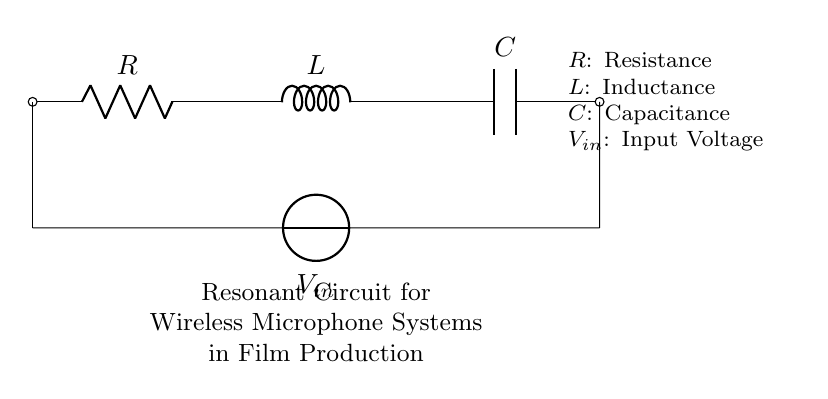What are the components in this circuit? The circuit includes a resistor, an inductor, and a capacitor, which are the basic components of a resonant circuit. Each component is labeled directly in the circuit diagram.
Answer: Resistor, Inductor, Capacitor What is the input voltage labeled as? The input voltage in the circuit is labeled as V_sub_in, which denotes the voltage provided to the circuit. This can be recognized by examining the voltage label directly on the circuit diagram.
Answer: V_sub_in How are the components connected in the circuit? The components are connected in series, starting from the resistor to the inductor, and then to the capacitor. This connection can be deduced by following the lines connecting each component in the circuit diagram.
Answer: In series What is the role of the resonant circuit in wireless microphone systems? The resonant circuit is utilized to filter and amplify the specific frequency signals transmitted by a wireless microphone, ensuring better signal clarity. This role is understood from the context of wireless transmission technologies used in microphone systems.
Answer: Signal filtering and amplification What is the effect of changing the resistance in this circuit? Changing the resistance affects the quality factor of the resonant circuit, which influences bandwidth and sensitivity. By analyzing the relationships among R, L, and C, we understand how resistance alters circuit behavior in resonant circuits.
Answer: Affects quality factor What is the relationship between resistance, inductance, and capacitance in determining resonance? The resonance frequency is determined by the formula f equals one over two pi times the square root of L times C. This shows that both inductance and capacitance are crucial in setting the resonant frequency, while resistance modifies the circuit's behavior at resonance.
Answer: Frequency equation What does the resonant frequency depend on specifically? The resonant frequency depends specifically on the values of inductance and capacitance in the circuit. The frequency can be calculated using the relation f equals one over two pi times the square root of L times C directly from the known relationships in circuit theory.
Answer: Inductance and Capacitance 